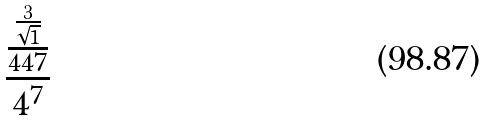Convert formula to latex. <formula><loc_0><loc_0><loc_500><loc_500>\frac { \frac { \frac { 3 } { \sqrt { 1 } } } { 4 4 7 } } { 4 ^ { 7 } }</formula> 